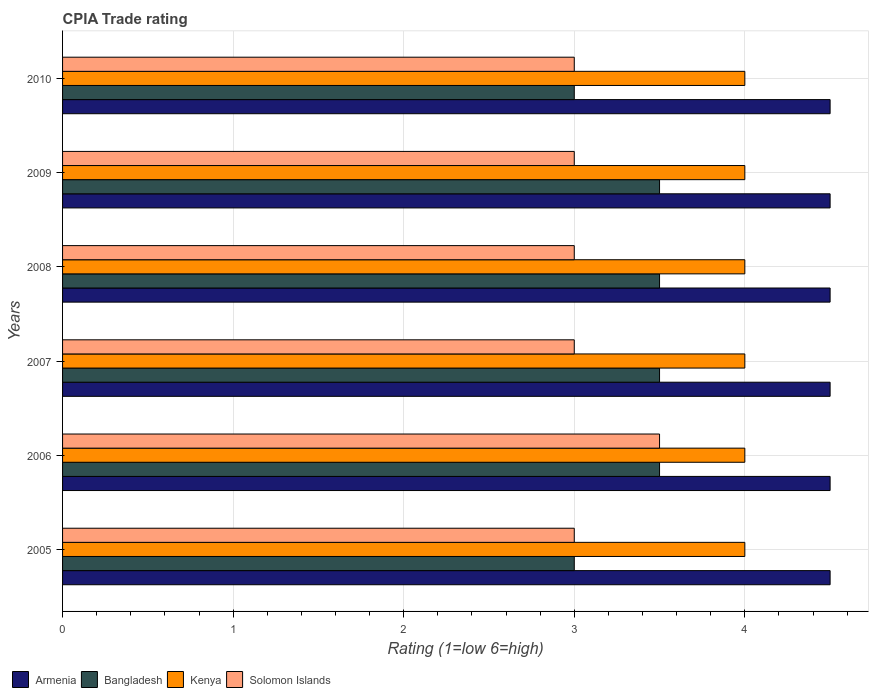How many different coloured bars are there?
Your answer should be compact. 4. How many groups of bars are there?
Your answer should be compact. 6. Are the number of bars per tick equal to the number of legend labels?
Keep it short and to the point. Yes. How many bars are there on the 2nd tick from the top?
Keep it short and to the point. 4. How many bars are there on the 2nd tick from the bottom?
Make the answer very short. 4. What is the label of the 4th group of bars from the top?
Your answer should be very brief. 2007. In how many cases, is the number of bars for a given year not equal to the number of legend labels?
Keep it short and to the point. 0. What is the CPIA rating in Solomon Islands in 2009?
Give a very brief answer. 3. Across all years, what is the maximum CPIA rating in Bangladesh?
Keep it short and to the point. 3.5. In which year was the CPIA rating in Bangladesh maximum?
Provide a short and direct response. 2006. What is the total CPIA rating in Kenya in the graph?
Offer a terse response. 24. What is the average CPIA rating in Armenia per year?
Provide a short and direct response. 4.5. In the year 2010, what is the difference between the CPIA rating in Kenya and CPIA rating in Bangladesh?
Offer a very short reply. 1. What is the ratio of the CPIA rating in Armenia in 2007 to that in 2008?
Offer a terse response. 1. Is the difference between the CPIA rating in Kenya in 2007 and 2009 greater than the difference between the CPIA rating in Bangladesh in 2007 and 2009?
Offer a very short reply. No. In how many years, is the CPIA rating in Bangladesh greater than the average CPIA rating in Bangladesh taken over all years?
Your answer should be very brief. 4. Is the sum of the CPIA rating in Kenya in 2007 and 2010 greater than the maximum CPIA rating in Armenia across all years?
Offer a terse response. Yes. What does the 2nd bar from the top in 2009 represents?
Provide a short and direct response. Kenya. What does the 1st bar from the bottom in 2008 represents?
Offer a very short reply. Armenia. Is it the case that in every year, the sum of the CPIA rating in Armenia and CPIA rating in Kenya is greater than the CPIA rating in Bangladesh?
Give a very brief answer. Yes. What is the difference between two consecutive major ticks on the X-axis?
Your answer should be compact. 1. Are the values on the major ticks of X-axis written in scientific E-notation?
Your response must be concise. No. Where does the legend appear in the graph?
Keep it short and to the point. Bottom left. What is the title of the graph?
Keep it short and to the point. CPIA Trade rating. Does "European Union" appear as one of the legend labels in the graph?
Ensure brevity in your answer.  No. What is the label or title of the X-axis?
Offer a very short reply. Rating (1=low 6=high). What is the Rating (1=low 6=high) of Kenya in 2005?
Ensure brevity in your answer.  4. What is the Rating (1=low 6=high) in Solomon Islands in 2005?
Ensure brevity in your answer.  3. What is the Rating (1=low 6=high) in Armenia in 2006?
Offer a terse response. 4.5. What is the Rating (1=low 6=high) of Kenya in 2006?
Your answer should be compact. 4. What is the Rating (1=low 6=high) of Solomon Islands in 2006?
Offer a very short reply. 3.5. What is the Rating (1=low 6=high) of Kenya in 2007?
Offer a very short reply. 4. What is the Rating (1=low 6=high) of Solomon Islands in 2008?
Offer a terse response. 3. What is the Rating (1=low 6=high) in Solomon Islands in 2009?
Ensure brevity in your answer.  3. What is the Rating (1=low 6=high) of Solomon Islands in 2010?
Offer a very short reply. 3. Across all years, what is the maximum Rating (1=low 6=high) in Armenia?
Offer a terse response. 4.5. Across all years, what is the minimum Rating (1=low 6=high) of Kenya?
Make the answer very short. 4. What is the total Rating (1=low 6=high) in Armenia in the graph?
Give a very brief answer. 27. What is the total Rating (1=low 6=high) of Bangladesh in the graph?
Offer a very short reply. 20. What is the total Rating (1=low 6=high) in Solomon Islands in the graph?
Offer a terse response. 18.5. What is the difference between the Rating (1=low 6=high) in Armenia in 2005 and that in 2006?
Ensure brevity in your answer.  0. What is the difference between the Rating (1=low 6=high) in Kenya in 2005 and that in 2006?
Offer a terse response. 0. What is the difference between the Rating (1=low 6=high) of Armenia in 2005 and that in 2007?
Provide a succinct answer. 0. What is the difference between the Rating (1=low 6=high) in Solomon Islands in 2005 and that in 2007?
Ensure brevity in your answer.  0. What is the difference between the Rating (1=low 6=high) in Kenya in 2005 and that in 2008?
Offer a terse response. 0. What is the difference between the Rating (1=low 6=high) in Solomon Islands in 2005 and that in 2008?
Offer a terse response. 0. What is the difference between the Rating (1=low 6=high) of Armenia in 2005 and that in 2009?
Your answer should be very brief. 0. What is the difference between the Rating (1=low 6=high) in Bangladesh in 2005 and that in 2009?
Offer a very short reply. -0.5. What is the difference between the Rating (1=low 6=high) in Kenya in 2005 and that in 2009?
Ensure brevity in your answer.  0. What is the difference between the Rating (1=low 6=high) in Bangladesh in 2005 and that in 2010?
Your answer should be very brief. 0. What is the difference between the Rating (1=low 6=high) in Armenia in 2006 and that in 2007?
Offer a very short reply. 0. What is the difference between the Rating (1=low 6=high) in Bangladesh in 2006 and that in 2007?
Keep it short and to the point. 0. What is the difference between the Rating (1=low 6=high) of Kenya in 2006 and that in 2007?
Provide a short and direct response. 0. What is the difference between the Rating (1=low 6=high) of Solomon Islands in 2006 and that in 2007?
Your answer should be compact. 0.5. What is the difference between the Rating (1=low 6=high) in Armenia in 2006 and that in 2008?
Keep it short and to the point. 0. What is the difference between the Rating (1=low 6=high) in Bangladesh in 2006 and that in 2008?
Ensure brevity in your answer.  0. What is the difference between the Rating (1=low 6=high) in Kenya in 2006 and that in 2008?
Provide a succinct answer. 0. What is the difference between the Rating (1=low 6=high) in Bangladesh in 2006 and that in 2009?
Your response must be concise. 0. What is the difference between the Rating (1=low 6=high) in Kenya in 2006 and that in 2009?
Offer a very short reply. 0. What is the difference between the Rating (1=low 6=high) of Armenia in 2006 and that in 2010?
Your answer should be compact. 0. What is the difference between the Rating (1=low 6=high) in Solomon Islands in 2006 and that in 2010?
Your response must be concise. 0.5. What is the difference between the Rating (1=low 6=high) of Armenia in 2007 and that in 2008?
Your response must be concise. 0. What is the difference between the Rating (1=low 6=high) of Bangladesh in 2007 and that in 2008?
Ensure brevity in your answer.  0. What is the difference between the Rating (1=low 6=high) of Kenya in 2007 and that in 2009?
Your response must be concise. 0. What is the difference between the Rating (1=low 6=high) in Solomon Islands in 2007 and that in 2009?
Provide a short and direct response. 0. What is the difference between the Rating (1=low 6=high) in Bangladesh in 2007 and that in 2010?
Your answer should be compact. 0.5. What is the difference between the Rating (1=low 6=high) in Solomon Islands in 2007 and that in 2010?
Give a very brief answer. 0. What is the difference between the Rating (1=low 6=high) of Bangladesh in 2008 and that in 2009?
Offer a very short reply. 0. What is the difference between the Rating (1=low 6=high) in Kenya in 2008 and that in 2009?
Make the answer very short. 0. What is the difference between the Rating (1=low 6=high) of Kenya in 2008 and that in 2010?
Offer a very short reply. 0. What is the difference between the Rating (1=low 6=high) in Armenia in 2009 and that in 2010?
Give a very brief answer. 0. What is the difference between the Rating (1=low 6=high) of Kenya in 2009 and that in 2010?
Make the answer very short. 0. What is the difference between the Rating (1=low 6=high) of Solomon Islands in 2009 and that in 2010?
Your answer should be compact. 0. What is the difference between the Rating (1=low 6=high) of Armenia in 2005 and the Rating (1=low 6=high) of Bangladesh in 2006?
Make the answer very short. 1. What is the difference between the Rating (1=low 6=high) in Bangladesh in 2005 and the Rating (1=low 6=high) in Kenya in 2006?
Your response must be concise. -1. What is the difference between the Rating (1=low 6=high) of Bangladesh in 2005 and the Rating (1=low 6=high) of Solomon Islands in 2006?
Your answer should be compact. -0.5. What is the difference between the Rating (1=low 6=high) in Kenya in 2005 and the Rating (1=low 6=high) in Solomon Islands in 2006?
Give a very brief answer. 0.5. What is the difference between the Rating (1=low 6=high) of Armenia in 2005 and the Rating (1=low 6=high) of Kenya in 2007?
Your answer should be very brief. 0.5. What is the difference between the Rating (1=low 6=high) in Armenia in 2005 and the Rating (1=low 6=high) in Solomon Islands in 2007?
Your response must be concise. 1.5. What is the difference between the Rating (1=low 6=high) of Bangladesh in 2005 and the Rating (1=low 6=high) of Solomon Islands in 2007?
Offer a terse response. 0. What is the difference between the Rating (1=low 6=high) in Kenya in 2005 and the Rating (1=low 6=high) in Solomon Islands in 2007?
Make the answer very short. 1. What is the difference between the Rating (1=low 6=high) in Armenia in 2005 and the Rating (1=low 6=high) in Bangladesh in 2008?
Your answer should be very brief. 1. What is the difference between the Rating (1=low 6=high) in Armenia in 2005 and the Rating (1=low 6=high) in Kenya in 2008?
Offer a very short reply. 0.5. What is the difference between the Rating (1=low 6=high) in Kenya in 2005 and the Rating (1=low 6=high) in Solomon Islands in 2008?
Offer a very short reply. 1. What is the difference between the Rating (1=low 6=high) in Armenia in 2005 and the Rating (1=low 6=high) in Kenya in 2009?
Provide a succinct answer. 0.5. What is the difference between the Rating (1=low 6=high) in Armenia in 2005 and the Rating (1=low 6=high) in Solomon Islands in 2009?
Provide a short and direct response. 1.5. What is the difference between the Rating (1=low 6=high) in Armenia in 2005 and the Rating (1=low 6=high) in Bangladesh in 2010?
Your response must be concise. 1.5. What is the difference between the Rating (1=low 6=high) in Armenia in 2005 and the Rating (1=low 6=high) in Kenya in 2010?
Provide a short and direct response. 0.5. What is the difference between the Rating (1=low 6=high) of Bangladesh in 2005 and the Rating (1=low 6=high) of Kenya in 2010?
Your response must be concise. -1. What is the difference between the Rating (1=low 6=high) in Armenia in 2006 and the Rating (1=low 6=high) in Bangladesh in 2007?
Offer a very short reply. 1. What is the difference between the Rating (1=low 6=high) in Armenia in 2006 and the Rating (1=low 6=high) in Kenya in 2007?
Ensure brevity in your answer.  0.5. What is the difference between the Rating (1=low 6=high) in Armenia in 2006 and the Rating (1=low 6=high) in Bangladesh in 2008?
Offer a very short reply. 1. What is the difference between the Rating (1=low 6=high) in Armenia in 2006 and the Rating (1=low 6=high) in Kenya in 2008?
Ensure brevity in your answer.  0.5. What is the difference between the Rating (1=low 6=high) of Bangladesh in 2006 and the Rating (1=low 6=high) of Solomon Islands in 2008?
Offer a terse response. 0.5. What is the difference between the Rating (1=low 6=high) in Kenya in 2006 and the Rating (1=low 6=high) in Solomon Islands in 2008?
Keep it short and to the point. 1. What is the difference between the Rating (1=low 6=high) in Armenia in 2006 and the Rating (1=low 6=high) in Kenya in 2009?
Your answer should be very brief. 0.5. What is the difference between the Rating (1=low 6=high) of Bangladesh in 2006 and the Rating (1=low 6=high) of Kenya in 2009?
Your response must be concise. -0.5. What is the difference between the Rating (1=low 6=high) in Kenya in 2006 and the Rating (1=low 6=high) in Solomon Islands in 2009?
Make the answer very short. 1. What is the difference between the Rating (1=low 6=high) in Armenia in 2006 and the Rating (1=low 6=high) in Bangladesh in 2010?
Your answer should be very brief. 1.5. What is the difference between the Rating (1=low 6=high) of Armenia in 2006 and the Rating (1=low 6=high) of Kenya in 2010?
Offer a terse response. 0.5. What is the difference between the Rating (1=low 6=high) in Armenia in 2007 and the Rating (1=low 6=high) in Bangladesh in 2008?
Offer a terse response. 1. What is the difference between the Rating (1=low 6=high) of Bangladesh in 2007 and the Rating (1=low 6=high) of Kenya in 2008?
Make the answer very short. -0.5. What is the difference between the Rating (1=low 6=high) in Bangladesh in 2007 and the Rating (1=low 6=high) in Solomon Islands in 2008?
Your answer should be compact. 0.5. What is the difference between the Rating (1=low 6=high) of Kenya in 2007 and the Rating (1=low 6=high) of Solomon Islands in 2008?
Make the answer very short. 1. What is the difference between the Rating (1=low 6=high) in Armenia in 2007 and the Rating (1=low 6=high) in Solomon Islands in 2009?
Give a very brief answer. 1.5. What is the difference between the Rating (1=low 6=high) of Armenia in 2007 and the Rating (1=low 6=high) of Bangladesh in 2010?
Your response must be concise. 1.5. What is the difference between the Rating (1=low 6=high) in Bangladesh in 2007 and the Rating (1=low 6=high) in Kenya in 2010?
Your answer should be compact. -0.5. What is the difference between the Rating (1=low 6=high) in Kenya in 2007 and the Rating (1=low 6=high) in Solomon Islands in 2010?
Provide a short and direct response. 1. What is the difference between the Rating (1=low 6=high) in Armenia in 2008 and the Rating (1=low 6=high) in Solomon Islands in 2009?
Make the answer very short. 1.5. What is the difference between the Rating (1=low 6=high) of Bangladesh in 2008 and the Rating (1=low 6=high) of Kenya in 2009?
Keep it short and to the point. -0.5. What is the difference between the Rating (1=low 6=high) in Kenya in 2008 and the Rating (1=low 6=high) in Solomon Islands in 2009?
Keep it short and to the point. 1. What is the difference between the Rating (1=low 6=high) in Armenia in 2008 and the Rating (1=low 6=high) in Bangladesh in 2010?
Keep it short and to the point. 1.5. What is the difference between the Rating (1=low 6=high) in Armenia in 2008 and the Rating (1=low 6=high) in Solomon Islands in 2010?
Keep it short and to the point. 1.5. What is the difference between the Rating (1=low 6=high) of Bangladesh in 2008 and the Rating (1=low 6=high) of Solomon Islands in 2010?
Provide a succinct answer. 0.5. What is the difference between the Rating (1=low 6=high) of Kenya in 2008 and the Rating (1=low 6=high) of Solomon Islands in 2010?
Provide a short and direct response. 1. What is the difference between the Rating (1=low 6=high) in Armenia in 2009 and the Rating (1=low 6=high) in Bangladesh in 2010?
Ensure brevity in your answer.  1.5. What is the difference between the Rating (1=low 6=high) of Armenia in 2009 and the Rating (1=low 6=high) of Solomon Islands in 2010?
Provide a short and direct response. 1.5. What is the difference between the Rating (1=low 6=high) in Bangladesh in 2009 and the Rating (1=low 6=high) in Kenya in 2010?
Your answer should be compact. -0.5. What is the average Rating (1=low 6=high) in Bangladesh per year?
Give a very brief answer. 3.33. What is the average Rating (1=low 6=high) of Kenya per year?
Offer a terse response. 4. What is the average Rating (1=low 6=high) of Solomon Islands per year?
Your answer should be compact. 3.08. In the year 2005, what is the difference between the Rating (1=low 6=high) of Armenia and Rating (1=low 6=high) of Bangladesh?
Ensure brevity in your answer.  1.5. In the year 2005, what is the difference between the Rating (1=low 6=high) in Armenia and Rating (1=low 6=high) in Kenya?
Your answer should be compact. 0.5. In the year 2005, what is the difference between the Rating (1=low 6=high) of Armenia and Rating (1=low 6=high) of Solomon Islands?
Your answer should be compact. 1.5. In the year 2005, what is the difference between the Rating (1=low 6=high) of Bangladesh and Rating (1=low 6=high) of Kenya?
Provide a short and direct response. -1. In the year 2005, what is the difference between the Rating (1=low 6=high) of Kenya and Rating (1=low 6=high) of Solomon Islands?
Give a very brief answer. 1. In the year 2006, what is the difference between the Rating (1=low 6=high) of Kenya and Rating (1=low 6=high) of Solomon Islands?
Your answer should be very brief. 0.5. In the year 2007, what is the difference between the Rating (1=low 6=high) of Armenia and Rating (1=low 6=high) of Kenya?
Provide a short and direct response. 0.5. In the year 2007, what is the difference between the Rating (1=low 6=high) in Armenia and Rating (1=low 6=high) in Solomon Islands?
Your response must be concise. 1.5. In the year 2007, what is the difference between the Rating (1=low 6=high) in Bangladesh and Rating (1=low 6=high) in Kenya?
Keep it short and to the point. -0.5. In the year 2007, what is the difference between the Rating (1=low 6=high) in Bangladesh and Rating (1=low 6=high) in Solomon Islands?
Offer a very short reply. 0.5. In the year 2008, what is the difference between the Rating (1=low 6=high) in Armenia and Rating (1=low 6=high) in Solomon Islands?
Your response must be concise. 1.5. In the year 2008, what is the difference between the Rating (1=low 6=high) in Bangladesh and Rating (1=low 6=high) in Kenya?
Keep it short and to the point. -0.5. In the year 2008, what is the difference between the Rating (1=low 6=high) in Bangladesh and Rating (1=low 6=high) in Solomon Islands?
Keep it short and to the point. 0.5. In the year 2008, what is the difference between the Rating (1=low 6=high) in Kenya and Rating (1=low 6=high) in Solomon Islands?
Your answer should be compact. 1. In the year 2009, what is the difference between the Rating (1=low 6=high) in Armenia and Rating (1=low 6=high) in Solomon Islands?
Provide a short and direct response. 1.5. In the year 2009, what is the difference between the Rating (1=low 6=high) of Bangladesh and Rating (1=low 6=high) of Solomon Islands?
Your answer should be very brief. 0.5. In the year 2010, what is the difference between the Rating (1=low 6=high) in Armenia and Rating (1=low 6=high) in Bangladesh?
Provide a succinct answer. 1.5. In the year 2010, what is the difference between the Rating (1=low 6=high) in Armenia and Rating (1=low 6=high) in Solomon Islands?
Your response must be concise. 1.5. In the year 2010, what is the difference between the Rating (1=low 6=high) of Bangladesh and Rating (1=low 6=high) of Kenya?
Ensure brevity in your answer.  -1. In the year 2010, what is the difference between the Rating (1=low 6=high) of Bangladesh and Rating (1=low 6=high) of Solomon Islands?
Provide a short and direct response. 0. What is the ratio of the Rating (1=low 6=high) of Bangladesh in 2005 to that in 2006?
Keep it short and to the point. 0.86. What is the ratio of the Rating (1=low 6=high) of Solomon Islands in 2005 to that in 2006?
Ensure brevity in your answer.  0.86. What is the ratio of the Rating (1=low 6=high) in Bangladesh in 2005 to that in 2007?
Offer a very short reply. 0.86. What is the ratio of the Rating (1=low 6=high) of Kenya in 2005 to that in 2007?
Offer a terse response. 1. What is the ratio of the Rating (1=low 6=high) of Bangladesh in 2005 to that in 2008?
Your answer should be very brief. 0.86. What is the ratio of the Rating (1=low 6=high) of Armenia in 2005 to that in 2010?
Ensure brevity in your answer.  1. What is the ratio of the Rating (1=low 6=high) in Solomon Islands in 2005 to that in 2010?
Your response must be concise. 1. What is the ratio of the Rating (1=low 6=high) of Armenia in 2006 to that in 2007?
Your answer should be very brief. 1. What is the ratio of the Rating (1=low 6=high) of Bangladesh in 2006 to that in 2007?
Your answer should be very brief. 1. What is the ratio of the Rating (1=low 6=high) in Kenya in 2006 to that in 2007?
Offer a very short reply. 1. What is the ratio of the Rating (1=low 6=high) of Solomon Islands in 2006 to that in 2007?
Make the answer very short. 1.17. What is the ratio of the Rating (1=low 6=high) in Kenya in 2006 to that in 2008?
Give a very brief answer. 1. What is the ratio of the Rating (1=low 6=high) of Solomon Islands in 2006 to that in 2008?
Your answer should be compact. 1.17. What is the ratio of the Rating (1=low 6=high) of Armenia in 2006 to that in 2009?
Your answer should be compact. 1. What is the ratio of the Rating (1=low 6=high) of Bangladesh in 2006 to that in 2009?
Keep it short and to the point. 1. What is the ratio of the Rating (1=low 6=high) in Kenya in 2006 to that in 2009?
Offer a very short reply. 1. What is the ratio of the Rating (1=low 6=high) of Solomon Islands in 2006 to that in 2009?
Provide a short and direct response. 1.17. What is the ratio of the Rating (1=low 6=high) of Armenia in 2006 to that in 2010?
Offer a terse response. 1. What is the ratio of the Rating (1=low 6=high) of Kenya in 2006 to that in 2010?
Ensure brevity in your answer.  1. What is the ratio of the Rating (1=low 6=high) in Armenia in 2007 to that in 2008?
Give a very brief answer. 1. What is the ratio of the Rating (1=low 6=high) in Bangladesh in 2007 to that in 2008?
Your response must be concise. 1. What is the ratio of the Rating (1=low 6=high) in Solomon Islands in 2007 to that in 2008?
Your answer should be very brief. 1. What is the ratio of the Rating (1=low 6=high) of Bangladesh in 2007 to that in 2009?
Your answer should be compact. 1. What is the ratio of the Rating (1=low 6=high) in Kenya in 2007 to that in 2009?
Your answer should be compact. 1. What is the ratio of the Rating (1=low 6=high) in Kenya in 2007 to that in 2010?
Give a very brief answer. 1. What is the ratio of the Rating (1=low 6=high) in Solomon Islands in 2007 to that in 2010?
Provide a short and direct response. 1. What is the ratio of the Rating (1=low 6=high) in Armenia in 2008 to that in 2009?
Keep it short and to the point. 1. What is the ratio of the Rating (1=low 6=high) of Kenya in 2008 to that in 2009?
Ensure brevity in your answer.  1. What is the ratio of the Rating (1=low 6=high) in Armenia in 2008 to that in 2010?
Offer a terse response. 1. What is the ratio of the Rating (1=low 6=high) in Bangladesh in 2008 to that in 2010?
Give a very brief answer. 1.17. What is the ratio of the Rating (1=low 6=high) in Kenya in 2008 to that in 2010?
Your response must be concise. 1. What is the ratio of the Rating (1=low 6=high) of Solomon Islands in 2008 to that in 2010?
Offer a very short reply. 1. What is the ratio of the Rating (1=low 6=high) of Kenya in 2009 to that in 2010?
Provide a short and direct response. 1. What is the ratio of the Rating (1=low 6=high) of Solomon Islands in 2009 to that in 2010?
Your answer should be compact. 1. What is the difference between the highest and the second highest Rating (1=low 6=high) of Kenya?
Offer a very short reply. 0. What is the difference between the highest and the lowest Rating (1=low 6=high) of Bangladesh?
Provide a short and direct response. 0.5. 